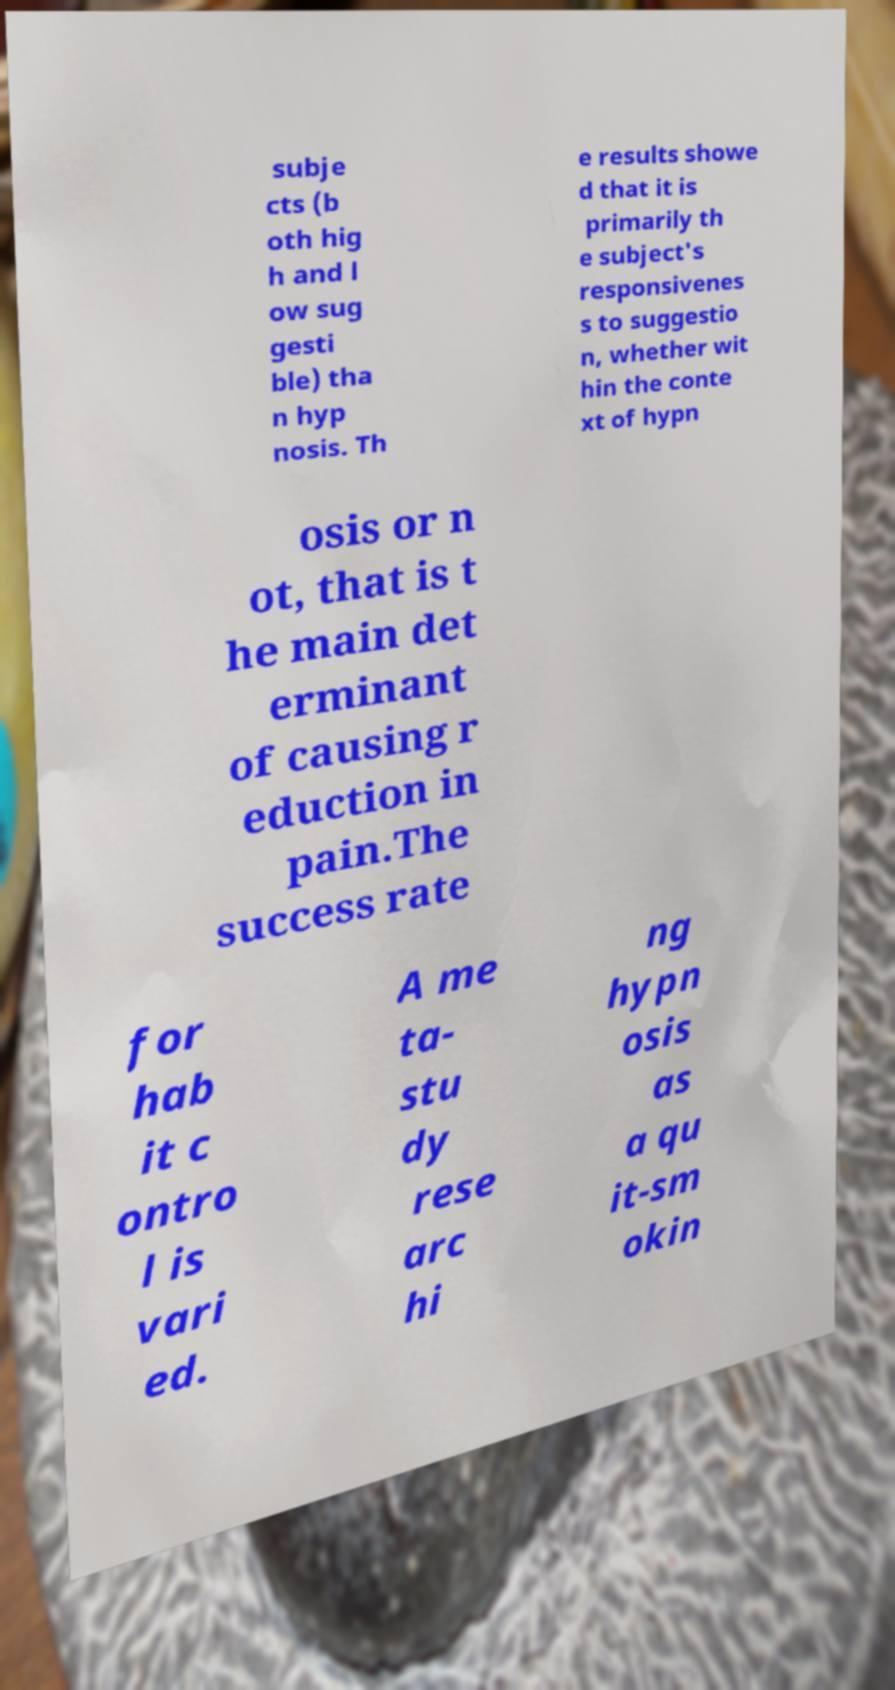For documentation purposes, I need the text within this image transcribed. Could you provide that? subje cts (b oth hig h and l ow sug gesti ble) tha n hyp nosis. Th e results showe d that it is primarily th e subject's responsivenes s to suggestio n, whether wit hin the conte xt of hypn osis or n ot, that is t he main det erminant of causing r eduction in pain.The success rate for hab it c ontro l is vari ed. A me ta- stu dy rese arc hi ng hypn osis as a qu it-sm okin 